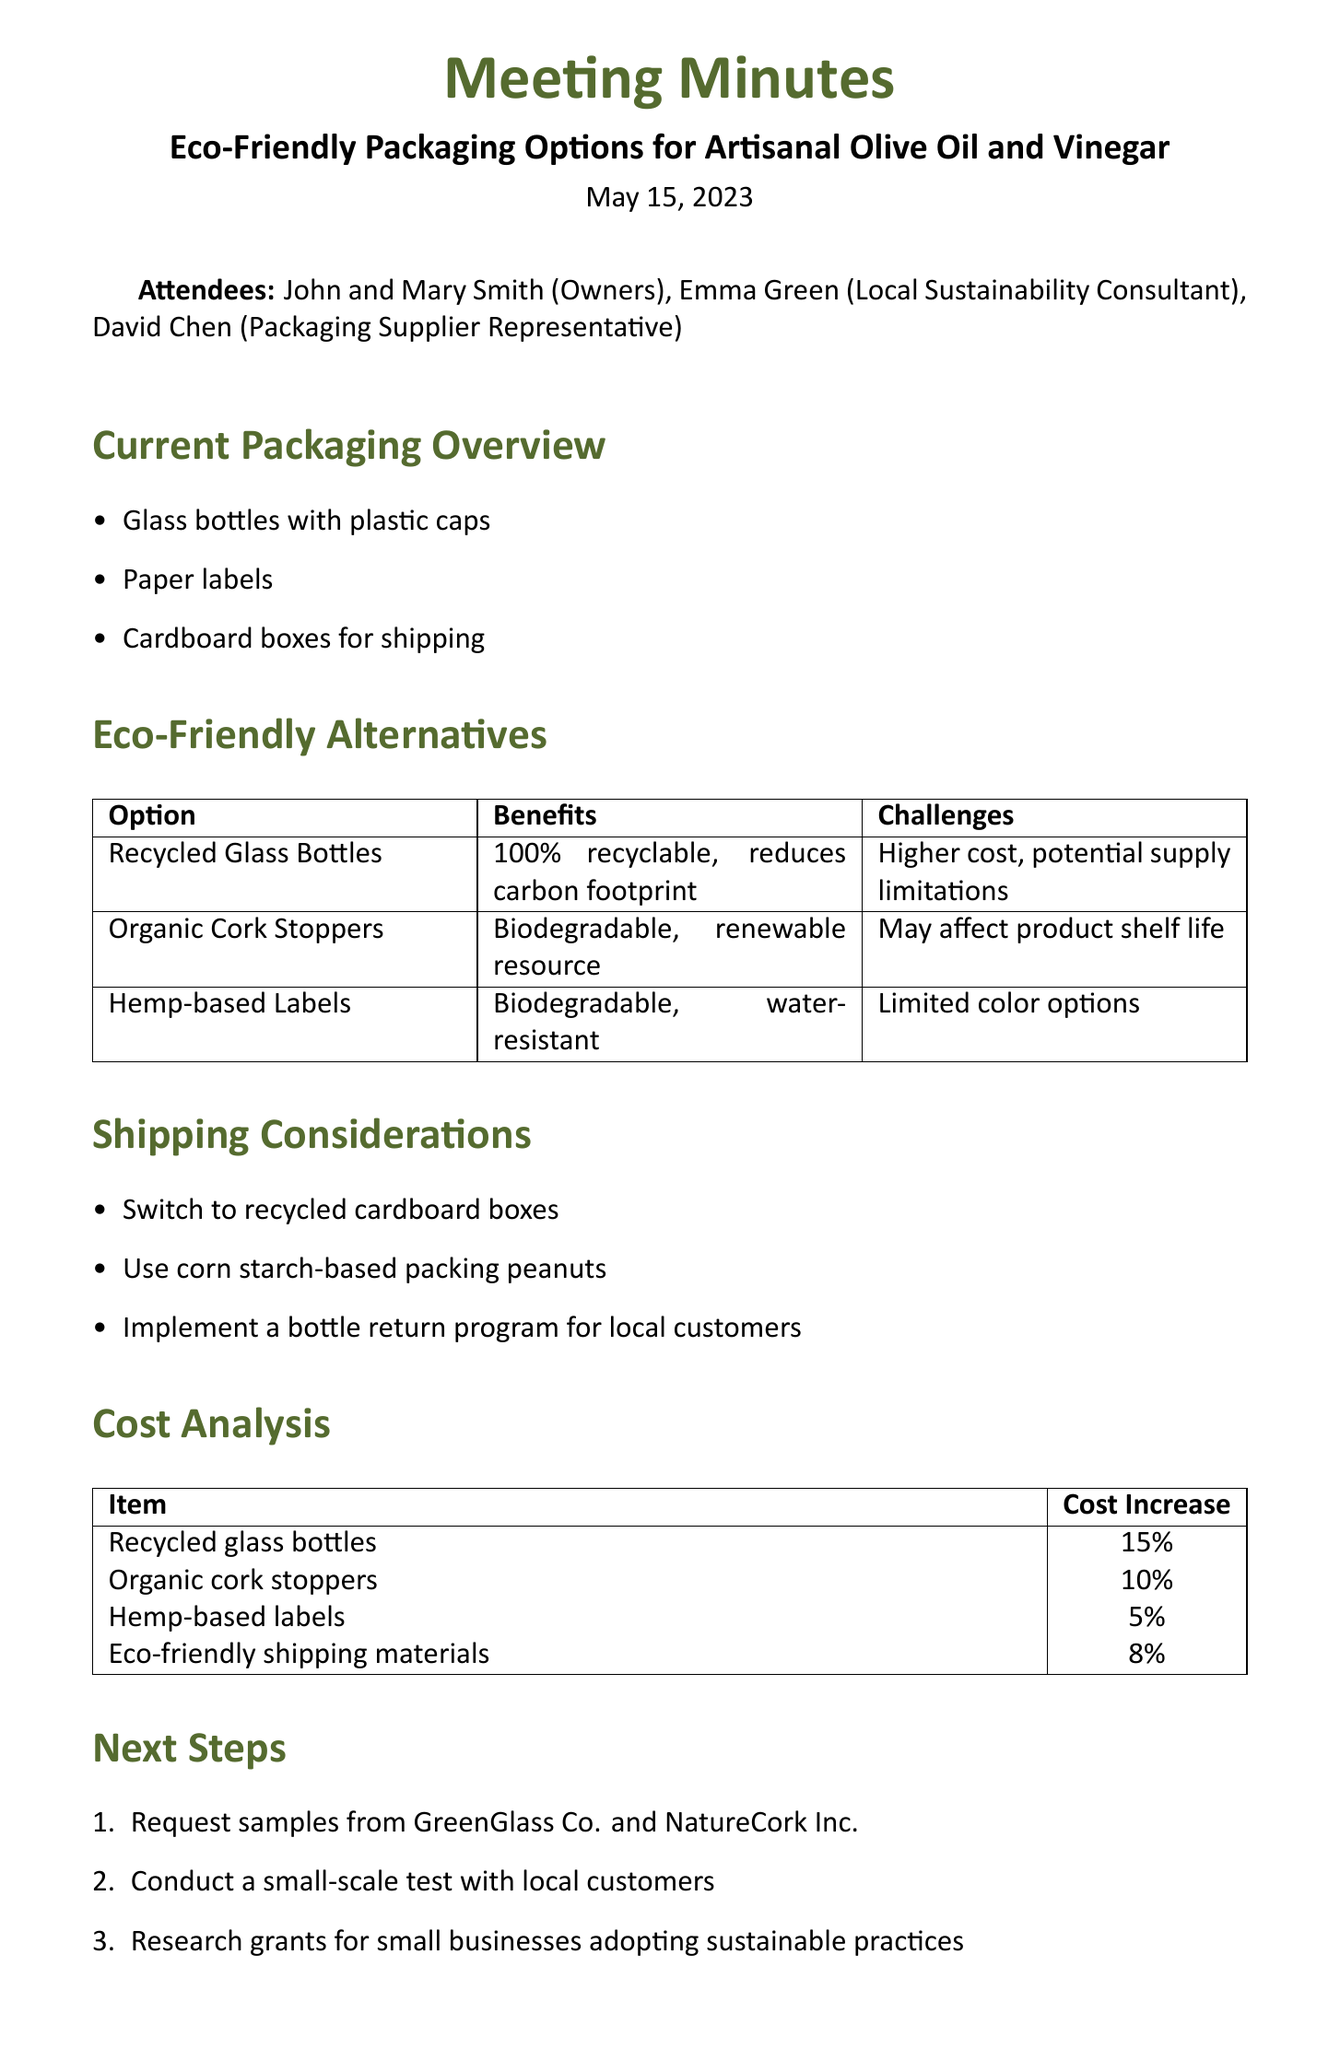What date was the meeting held? The date of the meeting is specified at the beginning of the document as May 15, 2023.
Answer: May 15, 2023 Who are the attendees? The attendees of the meeting include the owners and other representatives as listed in the document.
Answer: John and Mary Smith, Emma Green, David Chen What is one current packaging item mentioned? One of the items listed in the current packaging overview is a type of packaging for the products.
Answer: Glass bottles with plastic caps Which eco-friendly option has a 10% cost increase? The cost analysis section includes a breakdown of cost increases for different options, one of which is 10%.
Answer: Organic cork stoppers What are the benefits of hemp-based labels? The eco-friendly alternatives section lists the benefits associated with hemp-based labels.
Answer: Biodegradable, water-resistant What are the next steps proposed after the meeting? The next steps include actions that were agreed upon, as detailed in the document.
Answer: Request samples from GreenGlass Co. and NatureCork Inc What shipping changes were discussed? The shipping considerations point out new materials or practices that could be adopted post-meeting.
Answer: Switch to recycled cardboard boxes Which supplier is associated with recycled glass bottles? The eco-friendly alternatives section names the supplier for the recycled glass bottles.
Answer: GreenGlass Co 